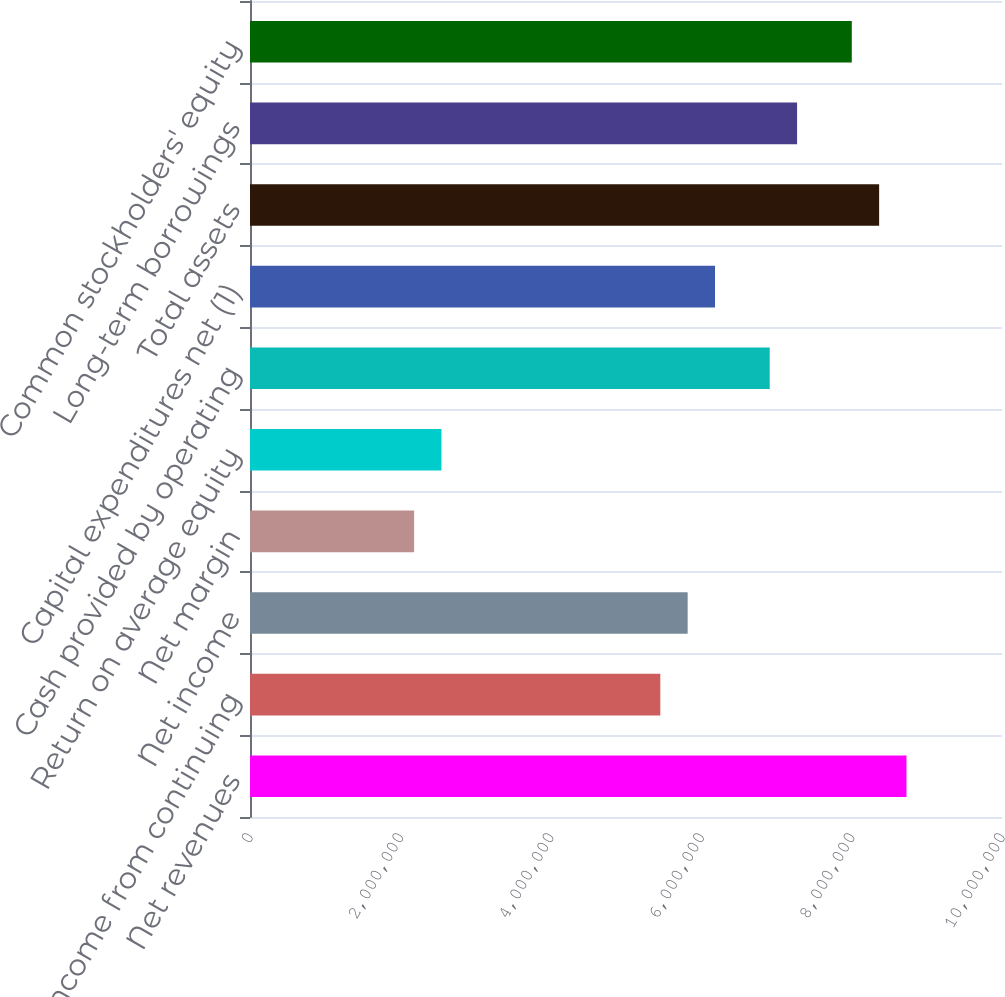<chart> <loc_0><loc_0><loc_500><loc_500><bar_chart><fcel>Net revenues<fcel>Net income from continuing<fcel>Net income<fcel>Net margin<fcel>Return on average equity<fcel>Cash provided by operating<fcel>Capital expenditures net (1)<fcel>Total assets<fcel>Long-term borrowings<fcel>Common stockholders' equity<nl><fcel>8.72998e+06<fcel>5.45623e+06<fcel>5.81998e+06<fcel>2.18249e+06<fcel>2.54624e+06<fcel>6.91123e+06<fcel>6.18373e+06<fcel>8.36623e+06<fcel>7.27498e+06<fcel>8.00248e+06<nl></chart> 